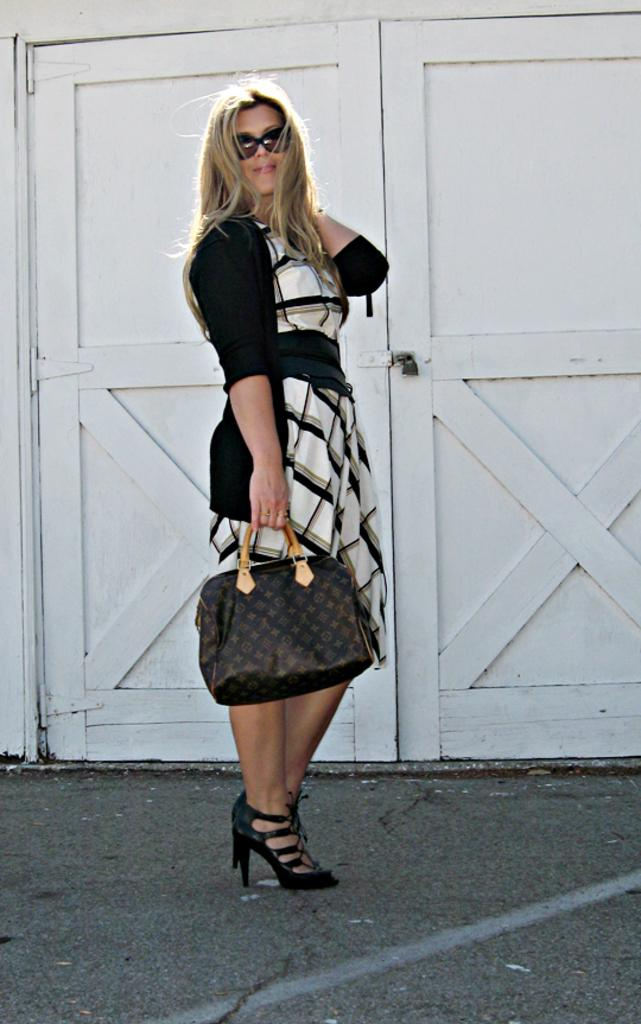Who is present in the image? There is a woman in the image. What is the woman wearing? The woman is wearing a jacket and goggles. What is the woman holding in one hand? The woman is carrying a bag in one hand. What can be seen in the background of the image? There is a door visible in the background of the image. What type of cup is the woman holding in the image? There is no cup present in the image. How many people are in the crowd behind the woman in the image? There is no crowd present in the image; it only features a woman and a door in the background. 